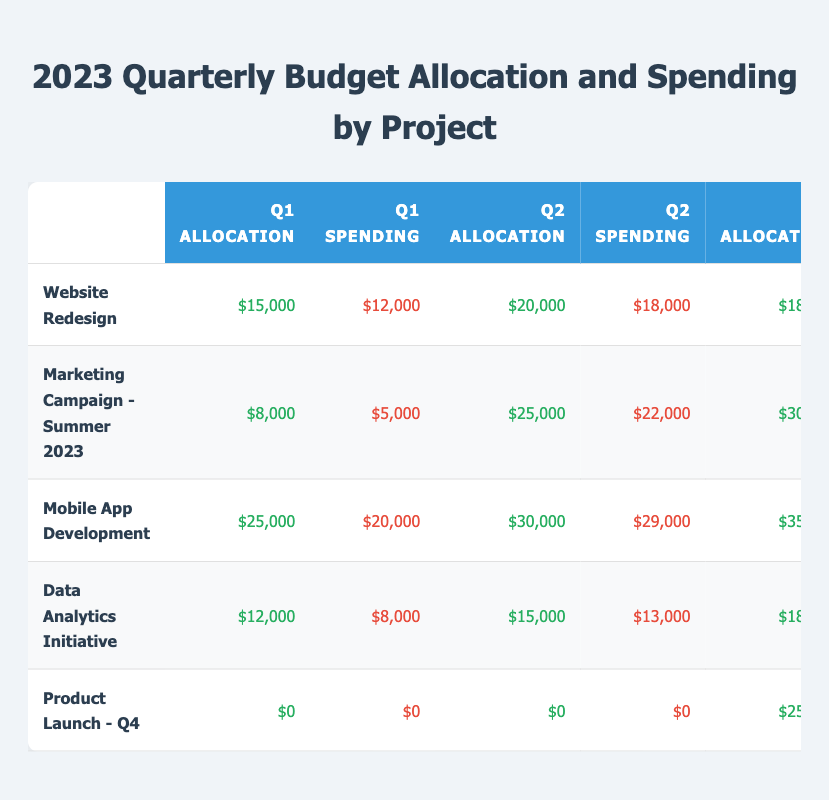What is the total budget allocation for the "Mobile App Development" project in 2023? To find the total budget allocation, sum the allocations for all four quarters: Q1 ($25,000) + Q2 ($30,000) + Q3 ($35,000) + Q4 ($20,000) = $110,000.
Answer: $110,000 What was the spending in the second quarter for the "Data Analytics Initiative"? The spending in the second quarter (Q2) for the "Data Analytics Initiative" is stated directly in the table as $13,000.
Answer: $13,000 Which project had the highest spending in Q1, and what was the amount? Comparing the spending in Q1 for all projects, "Mobile App Development" spent $20,000, which is the highest among all listed projects.
Answer: Mobile App Development, $20,000 Did the "Product Launch - Q4" receive any budget allocation during the first half of the year? The budget allocation for "Product Launch - Q4" is $0 for both Q1 and Q2, meaning it did not receive any allocation during the first half of the year.
Answer: No What is the average spending across all projects for Q3? Calculate the spending for Q3: $15,000 (Website Redesign) + $29,000 (Marketing Campaign) + $34,000 (Mobile App Development) + $17,000 (Data Analytics Initiative) + $24,000 (Product Launch) = $119,000. Divide by 5 (the number of projects) gives $119,000 / 5 = $23,800.
Answer: $23,800 Which project had the greatest difference between budget allocation and spending in Q2? In Q2, the budget allocation minus spending for each project is: Website Redesign: $20,000 - $18,000 = $2,000; Marketing Campaign: $25,000 - $22,000 = $3,000; Mobile App Development: $30,000 - $29,000 = $1,000; Data Analytics Initiative: $15,000 - $13,000 = $2,000; Product Launch: $0 - $0 = $0. The highest difference is $3,000 for the "Marketing Campaign."
Answer: Marketing Campaign - Summer 2023, $3,000 What was the total spending in the fourth quarter for all projects combined? Sum the spending for Q4 across all projects: $14,000 (Website Redesign) + $8,000 (Marketing Campaign) + $17,000 (Mobile App Development) + $19,000 (Data Analytics Initiative) + $48,000 (Product Launch) = $106,000.
Answer: $106,000 Is the total budget allocation for "Website Redesign" lower than that for "Marketing Campaign - Summer 2023"? The total allocation for "Website Redesign" is $15,000 + $20,000 + $18,000 + $16,000 = $69,000. For "Marketing Campaign," it's $8,000 + $25,000 + $30,000 + $9,000 = $72,000. Since $69,000 < $72,000, the statement is true.
Answer: Yes Which project had the lowest budget allocation in Q1, and what was the amount? Check the Q1 allocations: Website Redesign: $15,000; Marketing Campaign: $8,000; Mobile App Development: $25,000; Data Analytics Initiative: $12,000; Product Launch: $0. The lowest is $0 from the "Product Launch."
Answer: Product Launch - Q4, $0 